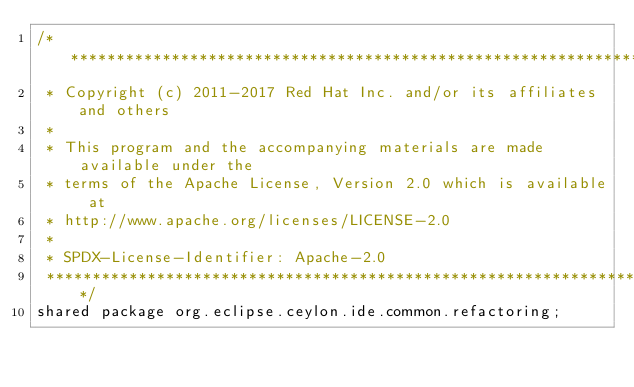Convert code to text. <code><loc_0><loc_0><loc_500><loc_500><_Ceylon_>/********************************************************************************
 * Copyright (c) 2011-2017 Red Hat Inc. and/or its affiliates and others
 *
 * This program and the accompanying materials are made available under the 
 * terms of the Apache License, Version 2.0 which is available at
 * http://www.apache.org/licenses/LICENSE-2.0
 *
 * SPDX-License-Identifier: Apache-2.0 
 ********************************************************************************/
shared package org.eclipse.ceylon.ide.common.refactoring;
</code> 